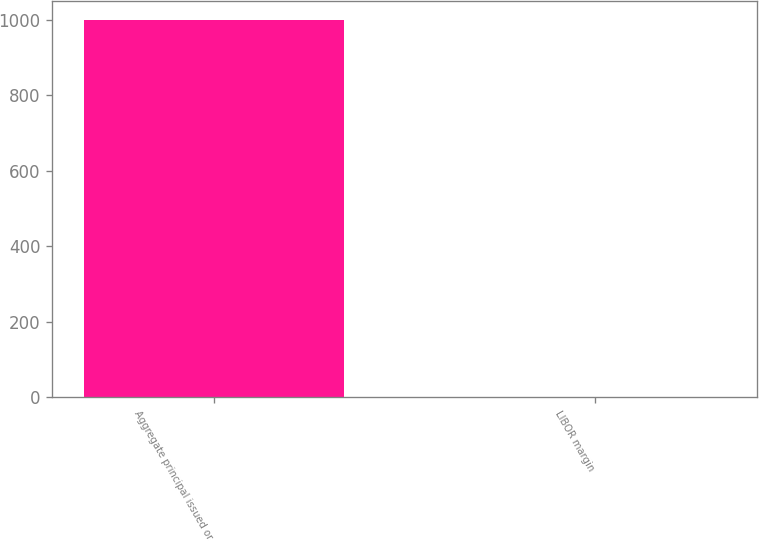Convert chart to OTSL. <chart><loc_0><loc_0><loc_500><loc_500><bar_chart><fcel>Aggregate principal issued or<fcel>LIBOR margin<nl><fcel>1000<fcel>2<nl></chart> 